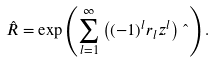<formula> <loc_0><loc_0><loc_500><loc_500>\hat { R } = \exp \left ( \sum _ { l = 1 } ^ { \infty } \left ( ( - 1 ) ^ { l } r _ { l } z ^ { l } \right ) \hat { \ } \right ) .</formula> 